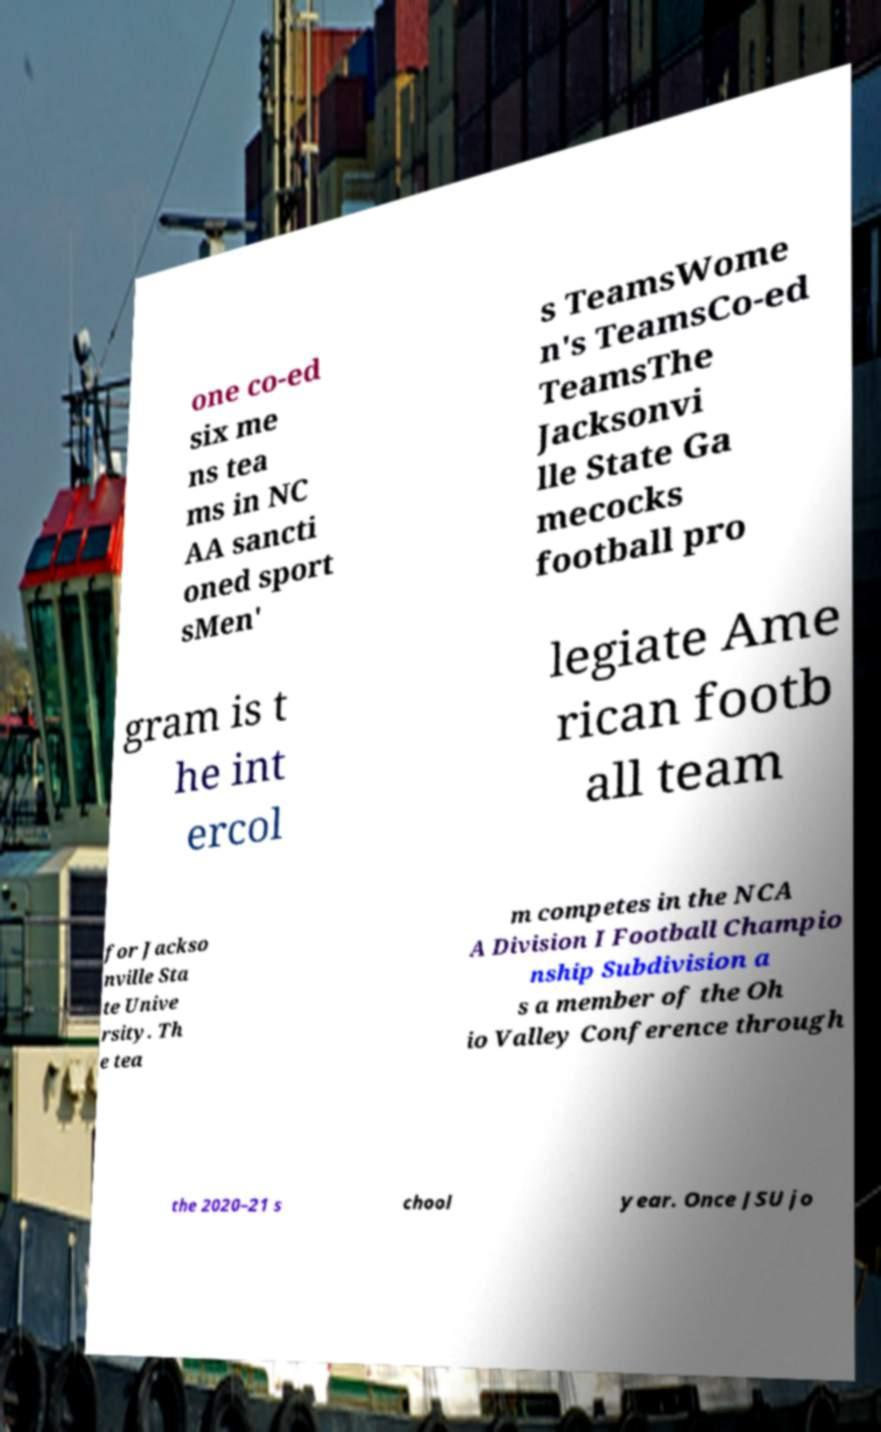Please read and relay the text visible in this image. What does it say? one co-ed six me ns tea ms in NC AA sancti oned sport sMen' s TeamsWome n's TeamsCo-ed TeamsThe Jacksonvi lle State Ga mecocks football pro gram is t he int ercol legiate Ame rican footb all team for Jackso nville Sta te Unive rsity. Th e tea m competes in the NCA A Division I Football Champio nship Subdivision a s a member of the Oh io Valley Conference through the 2020–21 s chool year. Once JSU jo 